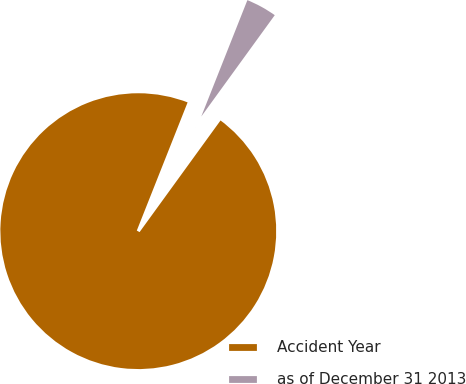<chart> <loc_0><loc_0><loc_500><loc_500><pie_chart><fcel>Accident Year<fcel>as of December 31 2013<nl><fcel>96.02%<fcel>3.98%<nl></chart> 